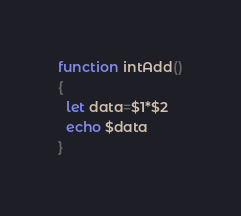Convert code to text. <code><loc_0><loc_0><loc_500><loc_500><_Bash_>function intAdd()
{
  let data=$1*$2
  echo $data
}
</code> 